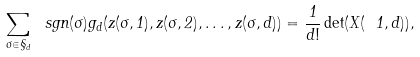Convert formula to latex. <formula><loc_0><loc_0><loc_500><loc_500>\sum _ { \sigma \in \S _ { d } } \ s g n ( \sigma ) g _ { d } ( z ( \sigma , 1 ) , z ( \sigma , 2 ) , \dots , z ( \sigma , d ) ) = \frac { 1 } { d ! } \det ( X ( \ 1 , d ) ) ,</formula> 